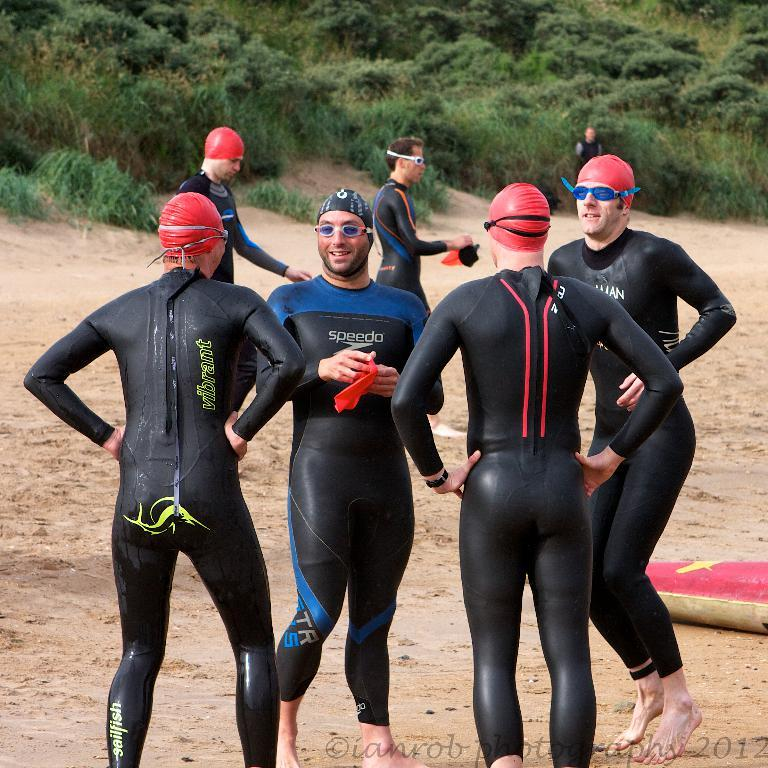How many people are present in the image? There are people in the image, but the exact number is not specified. What type of headgear can be seen on some of the people? Some people are wearing caps in the image. What type of eye protection is worn by some of the people? Some people are wearing goggles in the image. What can be seen in the background of the image? There are plants in the background of the image. What is present at the bottom of the image? There is text at the bottom of the image. What type of jeans is the judge wearing in the image? There is no judge or jeans present in the image. What type of crown is the queen wearing in the image? There is no queen or crown present in the image. 